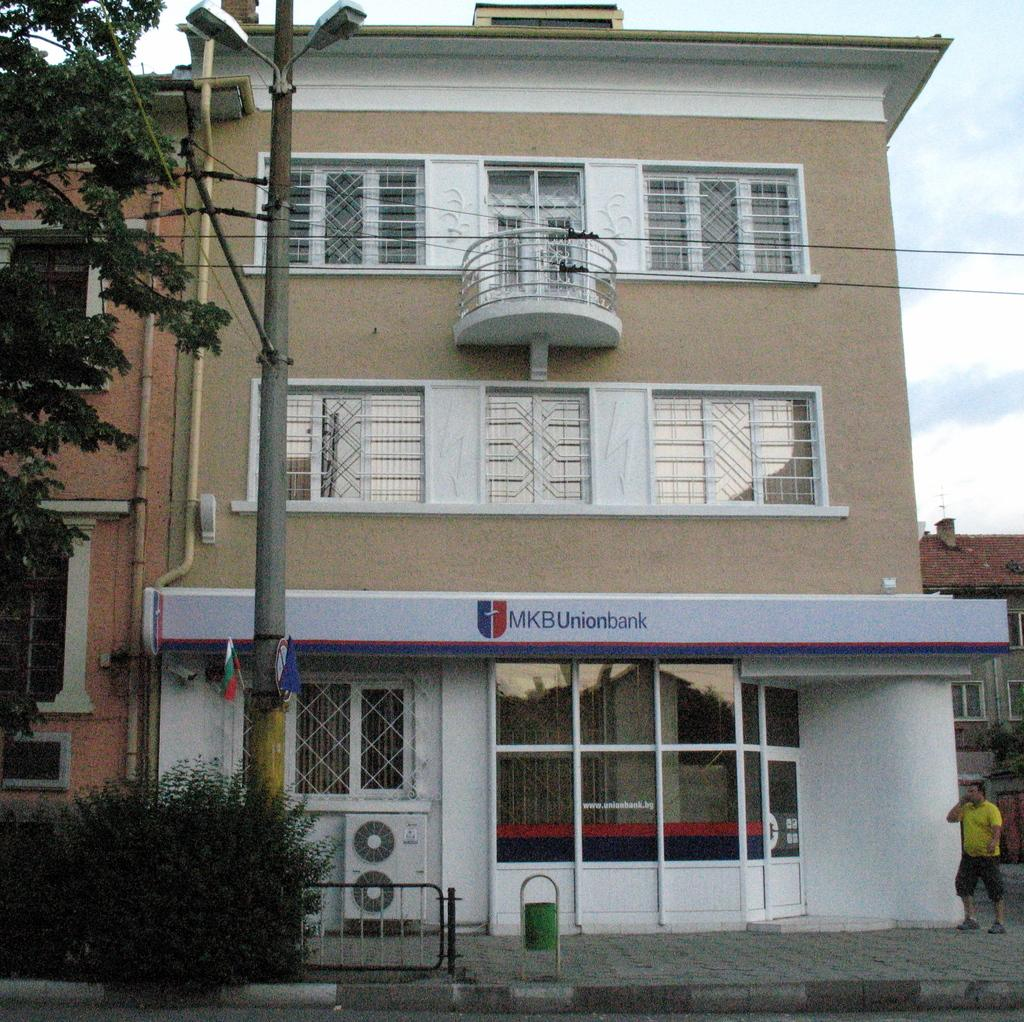What type of structures can be seen in the image? There are buildings in the image. What type of vegetation is present in the image? There are trees and shrubs in the image. What is located in front of the buildings? There is a pole, air conditioners, and a man in front of the buildings. What can be seen on the wall in the image? There are pipes on the wall in the image. Can you see a cactus growing next to the man in the image? There is no cactus present in the image. Is there a chicken walking around the buildings in the image? There is no chicken present in the image. 